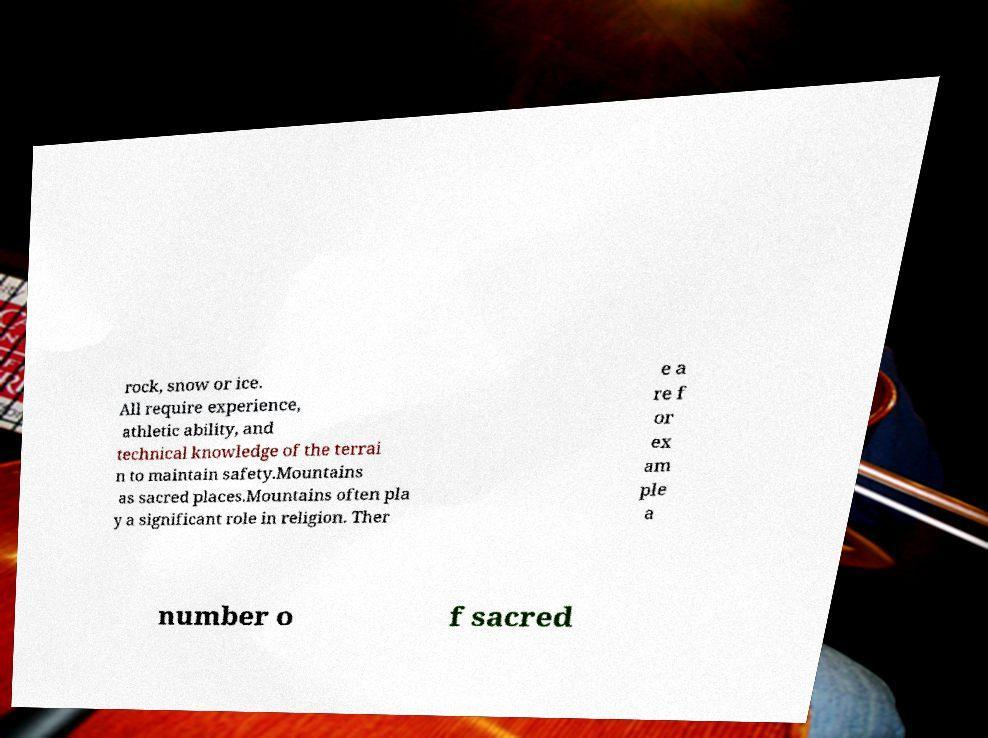Can you accurately transcribe the text from the provided image for me? rock, snow or ice. All require experience, athletic ability, and technical knowledge of the terrai n to maintain safety.Mountains as sacred places.Mountains often pla y a significant role in religion. Ther e a re f or ex am ple a number o f sacred 